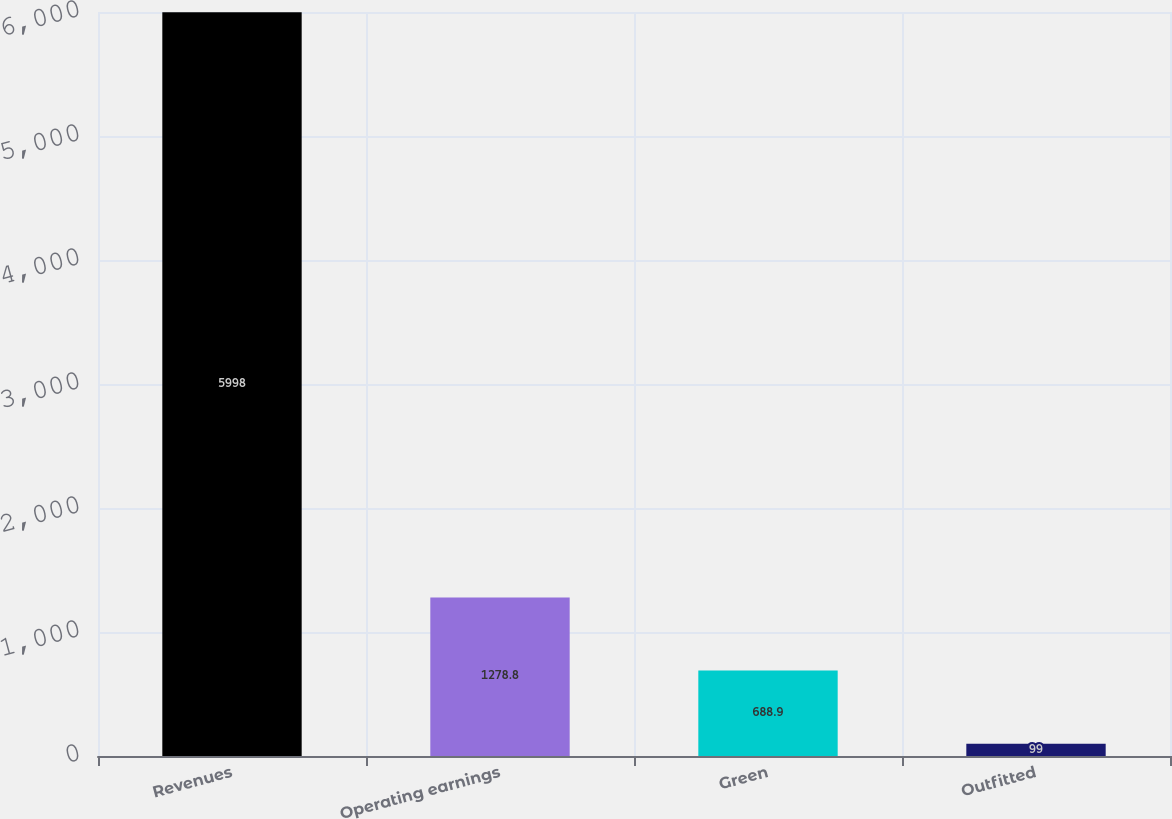Convert chart to OTSL. <chart><loc_0><loc_0><loc_500><loc_500><bar_chart><fcel>Revenues<fcel>Operating earnings<fcel>Green<fcel>Outfitted<nl><fcel>5998<fcel>1278.8<fcel>688.9<fcel>99<nl></chart> 